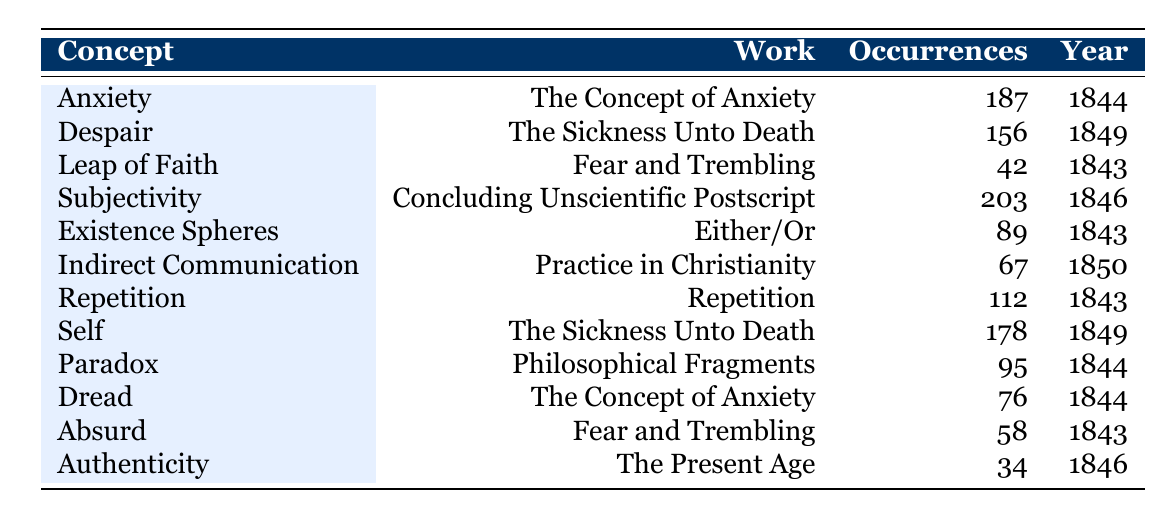What is the concept with the highest number of occurrences? By looking at the table, "Subjectivity" occurs 203 times, which is more than any other concept listed.
Answer: Subjectivity Which two works mention the concept of "Self"? The concept of "Self" appears in "The Sickness Unto Death" and also in the description, but no other works are listed for this concept.
Answer: The Sickness Unto Death How many occurrences does "Authenticity" have? The table states that "Authenticity" occurs 34 times, making it the least mentioned concept in the texts provided.
Answer: 34 What is the average number of occurrences of the concepts listed? To find the average, sum up all occurrences: 187 + 156 + 42 + 203 + 89 + 67 + 112 + 178 + 95 + 76 + 58 + 34 = 1,182. There are 12 concepts, so the average is 1,182 / 12 = 98.5.
Answer: 98.5 Which concept appears in the work "Fear and Trembling"? The concepts listed in "Fear and Trembling" are "Leap of Faith" and "Absurd," as indicated in the table.
Answer: Leap of Faith, Absurd Is "Dread" mentioned in more works than "Authenticity"? "Dread" appears in "The Concept of Anxiety", while "Authenticity" only appears in "The Present Age." Therefore, "Dread" is mentioned in more works.
Answer: Yes How many more occurrences does "Despair" have than "Absurd"? "Despair" has 156 occurrences, and "Absurd" has 58 occurrences; the difference is 156 - 58 = 98.
Answer: 98 Which concepts were discussed in 1843? The concepts from 1843 include "Leap of Faith," "Existence Spheres," and "Repetition."
Answer: Leap of Faith, Existence Spheres, Repetition What is the total number of occurrences for concepts discussed in "The Sickness Unto Death"? "Despair" has 156 occurrences and "Self" has 178 occurrences; adding these gives 156 + 178 = 334.
Answer: 334 What year saw the publication of the most works? By examining the years, 1843 has three works ("Leap of Faith," "Existence Spheres," and "Repetition"), which is the most.
Answer: 1843 